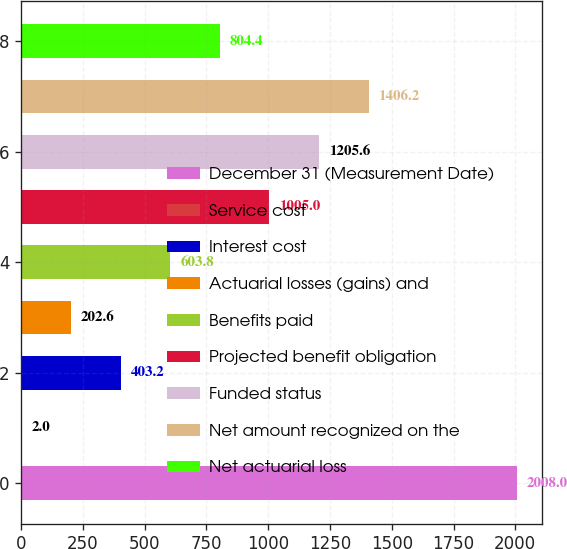Convert chart. <chart><loc_0><loc_0><loc_500><loc_500><bar_chart><fcel>December 31 (Measurement Date)<fcel>Service cost<fcel>Interest cost<fcel>Actuarial losses (gains) and<fcel>Benefits paid<fcel>Projected benefit obligation<fcel>Funded status<fcel>Net amount recognized on the<fcel>Net actuarial loss<nl><fcel>2008<fcel>2<fcel>403.2<fcel>202.6<fcel>603.8<fcel>1005<fcel>1205.6<fcel>1406.2<fcel>804.4<nl></chart> 